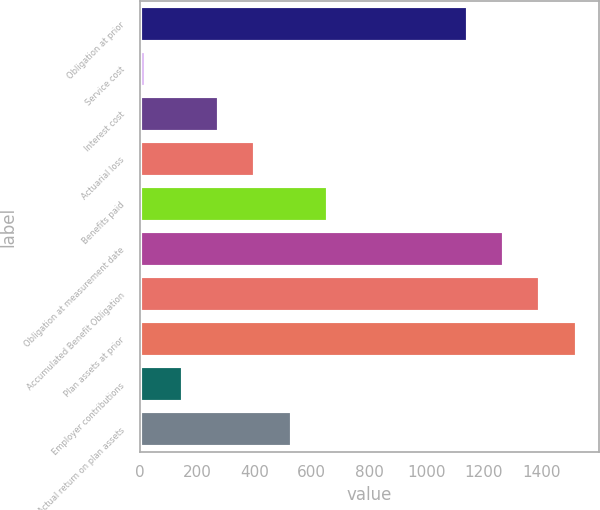<chart> <loc_0><loc_0><loc_500><loc_500><bar_chart><fcel>Obligation at prior<fcel>Service cost<fcel>Interest cost<fcel>Actuarial loss<fcel>Benefits paid<fcel>Obligation at measurement date<fcel>Accumulated Benefit Obligation<fcel>Plan assets at prior<fcel>Employer contributions<fcel>Actual return on plan assets<nl><fcel>1143<fcel>24<fcel>277.2<fcel>403.8<fcel>657<fcel>1269.6<fcel>1396.2<fcel>1522.8<fcel>150.6<fcel>530.4<nl></chart> 